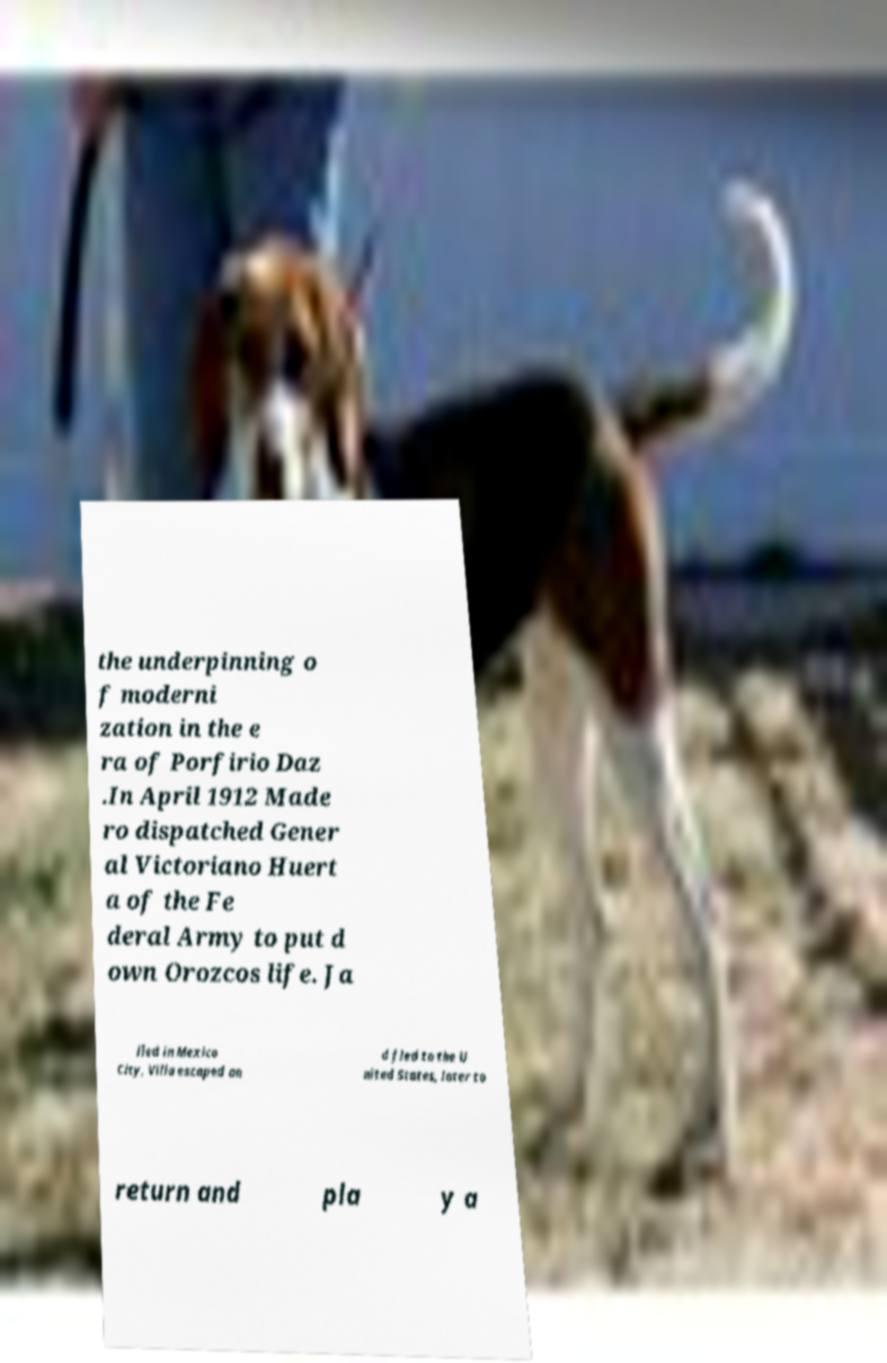Please read and relay the text visible in this image. What does it say? the underpinning o f moderni zation in the e ra of Porfirio Daz .In April 1912 Made ro dispatched Gener al Victoriano Huert a of the Fe deral Army to put d own Orozcos life. Ja iled in Mexico City, Villa escaped an d fled to the U nited States, later to return and pla y a 